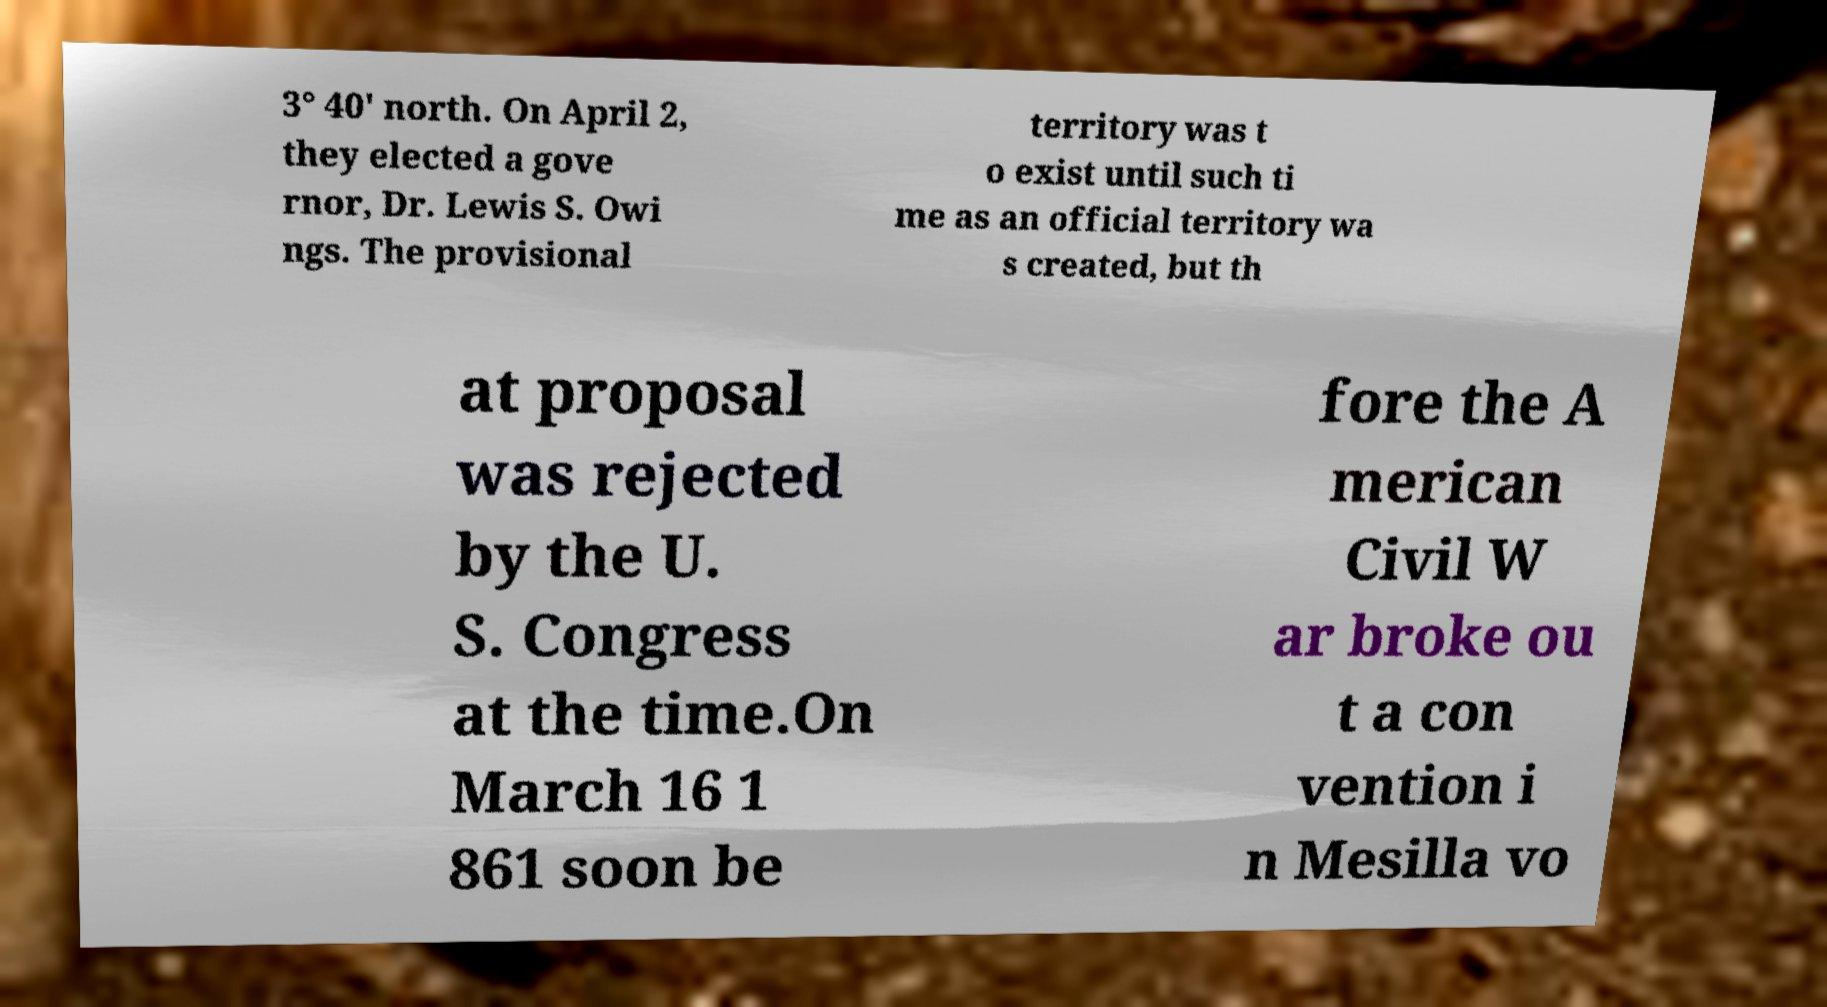Could you extract and type out the text from this image? 3° 40' north. On April 2, they elected a gove rnor, Dr. Lewis S. Owi ngs. The provisional territory was t o exist until such ti me as an official territory wa s created, but th at proposal was rejected by the U. S. Congress at the time.On March 16 1 861 soon be fore the A merican Civil W ar broke ou t a con vention i n Mesilla vo 